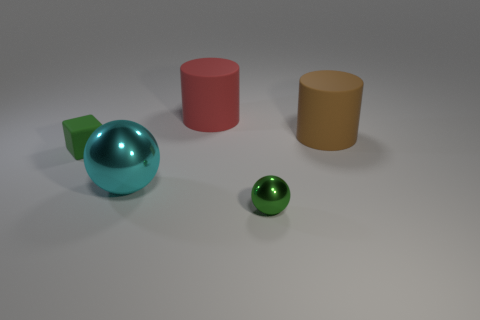Is the number of red cylinders greater than the number of large cylinders?
Make the answer very short. No. What number of matte things are either cylinders or big balls?
Provide a short and direct response. 2. How many small balls have the same color as the tiny matte object?
Provide a short and direct response. 1. What material is the object behind the cylinder right of the small object that is on the right side of the small block?
Your answer should be very brief. Rubber. What is the color of the small thing that is right of the tiny object that is behind the green sphere?
Ensure brevity in your answer.  Green. How many large things are green shiny things or cylinders?
Give a very brief answer. 2. What number of red cylinders are made of the same material as the green cube?
Offer a terse response. 1. There is a brown rubber thing that is right of the cyan thing; what is its size?
Offer a very short reply. Large. The large red rubber object that is behind the tiny object that is in front of the large cyan metallic ball is what shape?
Keep it short and to the point. Cylinder. There is a tiny object behind the sphere left of the large red cylinder; what number of matte things are to the right of it?
Provide a short and direct response. 2. 